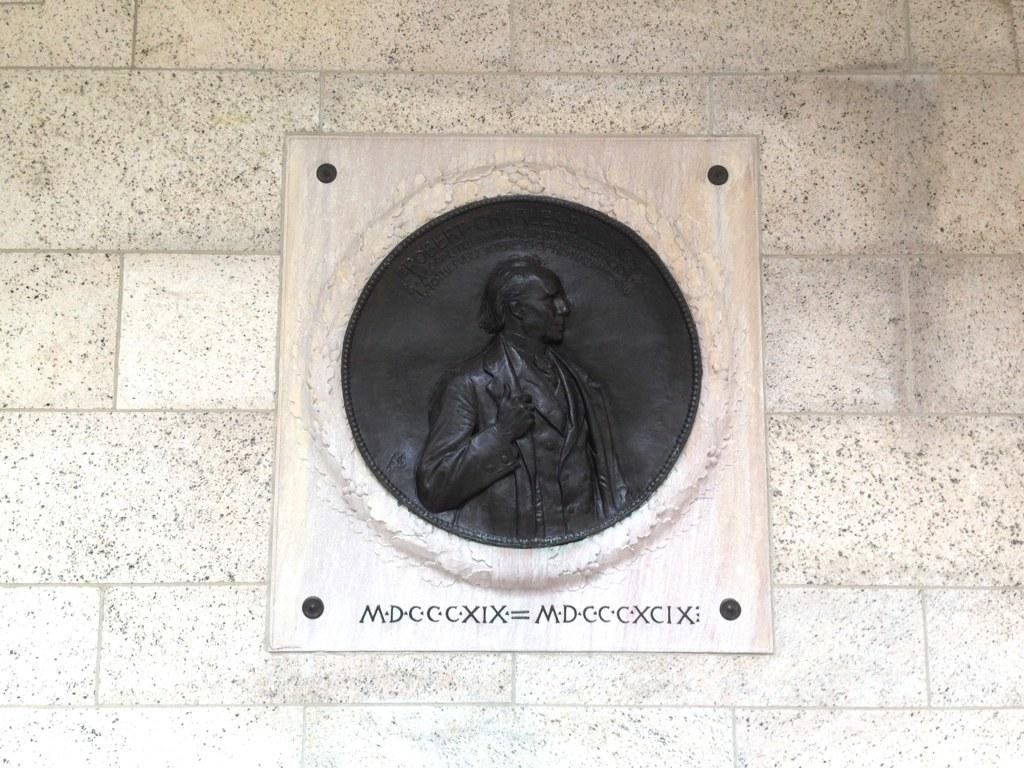What is present on the wall in the image? There is a board attached to the wall in the image. What can be seen on the board? There is a black colored carving on the board. Is there any text on the board? Yes, something is written at the bottom of the board. How many cows are depicted on the board in the image? There are no cows depicted on the board in the image. What type of spoon is used to carve the design on the board? There is no spoon mentioned or visible in the image; the carving was done using a different tool. 